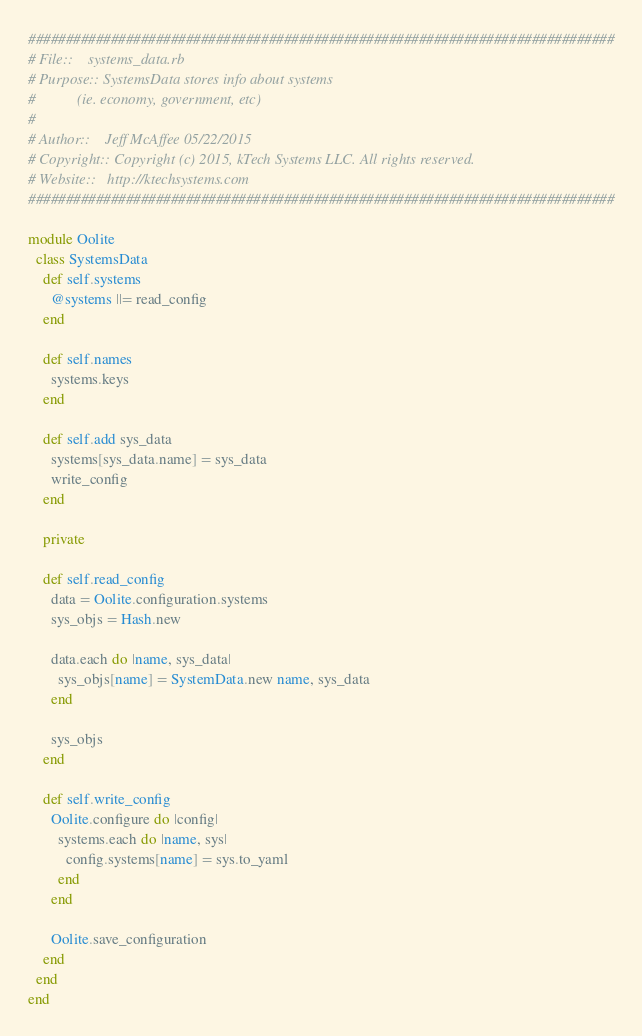<code> <loc_0><loc_0><loc_500><loc_500><_Ruby_>##############################################################################
# File::    systems_data.rb
# Purpose:: SystemsData stores info about systems
#           (ie. economy, government, etc)
#
# Author::    Jeff McAffee 05/22/2015
# Copyright:: Copyright (c) 2015, kTech Systems LLC. All rights reserved.
# Website::   http://ktechsystems.com
##############################################################################

module Oolite
  class SystemsData
    def self.systems
      @systems ||= read_config
    end

    def self.names
      systems.keys
    end

    def self.add sys_data
      systems[sys_data.name] = sys_data
      write_config
    end

    private

    def self.read_config
      data = Oolite.configuration.systems
      sys_objs = Hash.new

      data.each do |name, sys_data|
        sys_objs[name] = SystemData.new name, sys_data
      end

      sys_objs
    end

    def self.write_config
      Oolite.configure do |config|
        systems.each do |name, sys|
          config.systems[name] = sys.to_yaml
        end
      end

      Oolite.save_configuration
    end
  end
end
</code> 